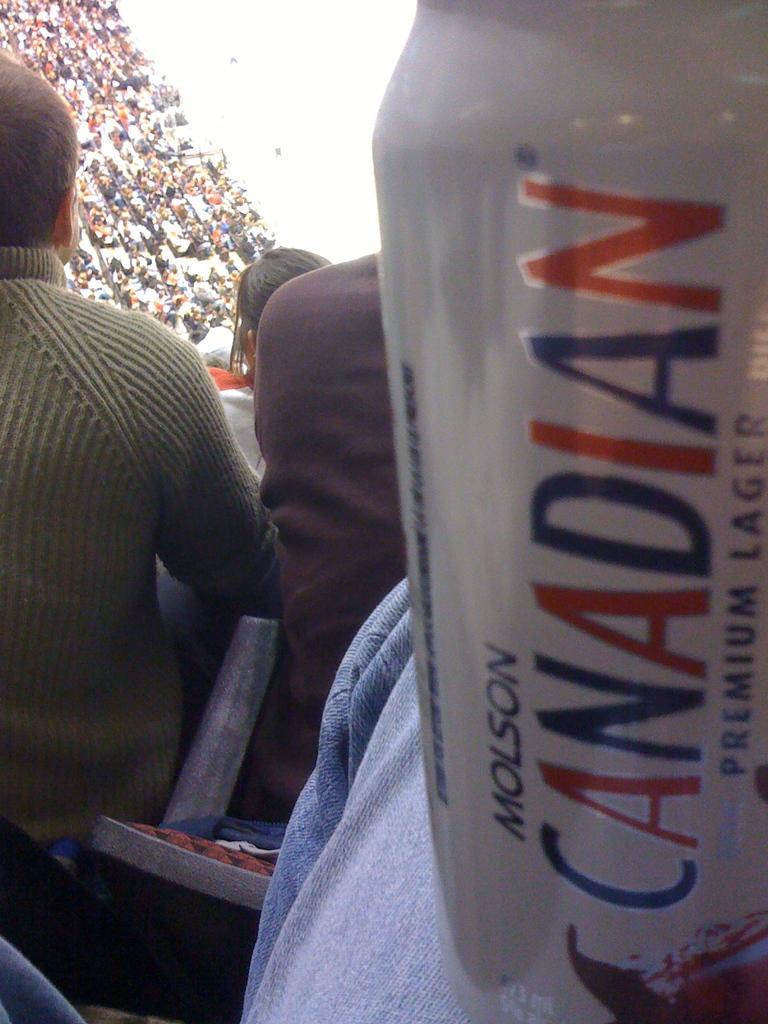Can you describe this image briefly? This image is taken in the stadium. On the left side of the image a few people are sitting on the chairs. On the right side of the image there is a can with a text on it. 